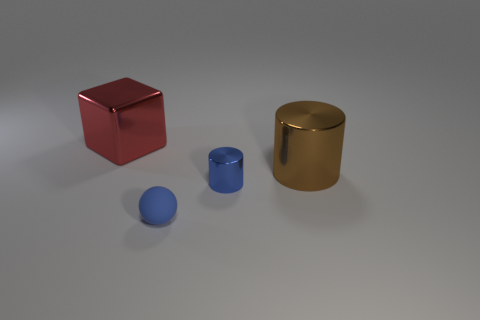Do the large block and the small shiny cylinder have the same color?
Make the answer very short. No. There is a cylinder that is the same color as the small ball; what is it made of?
Make the answer very short. Metal. Are there fewer rubber things in front of the ball than red metal blocks that are behind the metal block?
Your answer should be very brief. No. Does the big brown cylinder have the same material as the big red thing?
Your response must be concise. Yes. There is a object that is right of the tiny blue rubber object and behind the small blue shiny thing; how big is it?
Keep it short and to the point. Large. Is the number of tiny red rubber spheres the same as the number of cylinders?
Provide a short and direct response. No. There is another blue object that is the same size as the blue rubber object; what is its shape?
Your answer should be compact. Cylinder. What is the material of the large thing right of the large metal thing that is to the left of the blue thing that is to the right of the blue ball?
Offer a very short reply. Metal. Does the large thing in front of the big red metallic object have the same shape as the object that is to the left of the small matte ball?
Provide a short and direct response. No. How many other things are made of the same material as the blue sphere?
Your response must be concise. 0. 